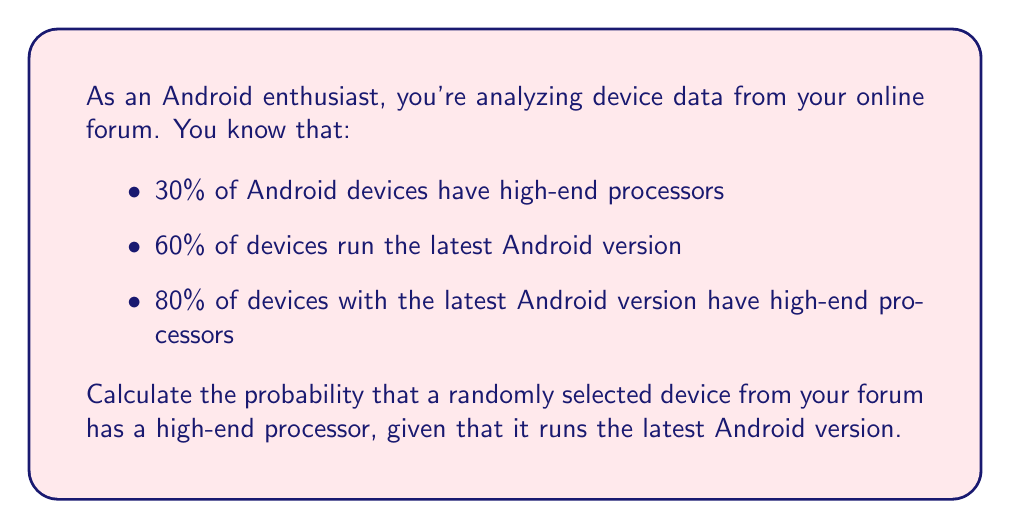Give your solution to this math problem. Let's approach this problem using Bayes' theorem. We'll define the following events:

H: The device has a high-end processor
L: The device runs the latest Android version

We're given the following probabilities:

$P(H) = 0.30$ (30% of devices have high-end processors)
$P(L) = 0.60$ (60% of devices run the latest Android version)
$P(L|H) = 0.80$ (80% of devices with the latest Android version have high-end processors)

We want to find $P(H|L)$, which is the probability that a device has a high-end processor given that it runs the latest Android version.

Bayes' theorem states:

$$P(H|L) = \frac{P(L|H) \cdot P(H)}{P(L)}$$

We know $P(L|H)$, $P(H)$, and $P(L)$, but we need to use $P(L|H)$ instead of $P(H|L)$. We can use the given information to calculate this:

$$P(H|L) = \frac{P(L|H) \cdot P(H)}{P(L)}$$

$$P(H|L) = \frac{0.80 \cdot 0.30}{0.60}$$

$$P(H|L) = \frac{0.24}{0.60}$$

$$P(H|L) = 0.40$$

Therefore, the probability that a randomly selected device from your forum has a high-end processor, given that it runs the latest Android version, is 0.40 or 40%.
Answer: 0.40 or 40% 